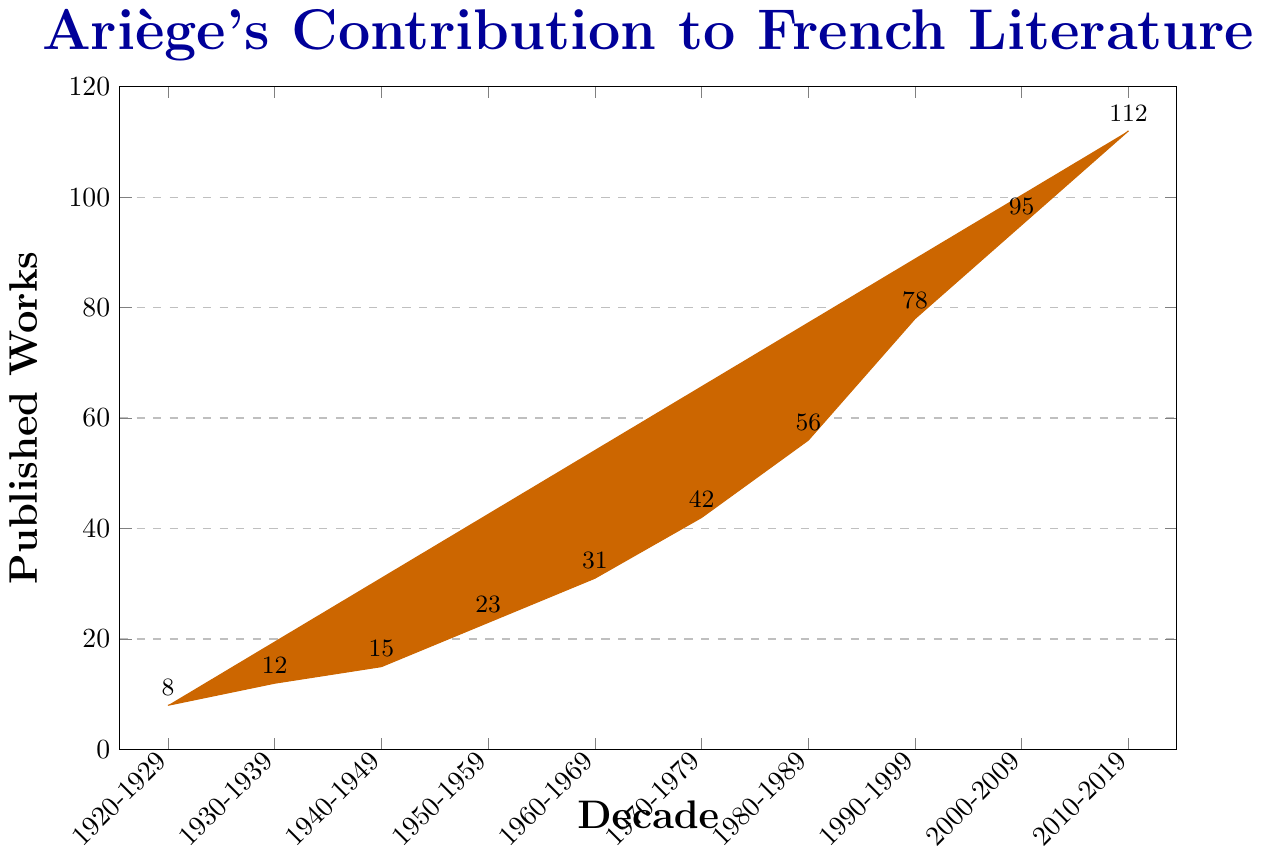What is the total number of published works from 1920 to 1959? Sum the values for the decades 1920-1929, 1930-1939, 1940-1949, and 1950-1959: 8 + 12 + 15 + 23
Answer: 58 Which decade saw the highest number of published works? Identify the tallest bar in the chart, which corresponds to 2010-2019 with 112 published works
Answer: 2010-2019 How does the number of published works in the 1960s compare to the 1970s? Compare the heights of the bars for 1960-1969 and 1970-1979. The values are 31 and 42 respectively. The 1970s have more published works
Answer: 1970s By how much did the number of published works increase from the 1980s to the 1990s? Subtract the number of published works in 1980-1989 (56) from that in 1990-1999 (78): 78 - 56
Answer: 22 What is the average number of published works per decade from 2000 to 2019? Sum the number of works for 2000-2009 and 2010-2019, then divide by 2: (95 + 112) / 2
Answer: 103.5 How many decades saw more than 50 published works? Count the bars representing more than 50 works. These are the bars for 1980s, 1990s, 2000s, and 2010s, so 4 decades
Answer: 4 What is the trend in the number of published works from 1920 to 2019? Observe the bars growing taller, indicating a consistent increase in published works over the decades
Answer: Increasing Which decade experienced the smallest growth in published works compared to the previous decade? Subtract the number of works in each decade from the previous one. The smallest difference is between the 1920s (8) and 1930s (12), amounting to 4 works
Answer: 1920s-1930s What percentage of the total published works from 1920 to 2019 were published in the decade 2000-2009? First, calculate the total published works: 8 + 12 + 15 + 23 + 31 + 42 + 56 + 78 + 95 + 112 = 472. Then, divide the number of works from 2000-2009 (95) by 472 and multiply by 100: (95 / 472) * 100
Answer: 20.13% 